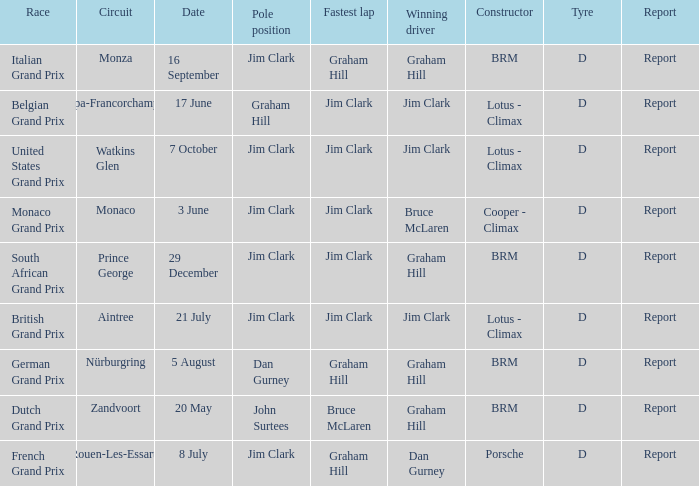What is the date of the circuit of Monaco? 3 June. 